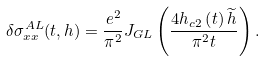<formula> <loc_0><loc_0><loc_500><loc_500>\delta \sigma _ { x x } ^ { A L } ( t , h ) = \frac { e ^ { 2 } } { \pi ^ { 2 } } J _ { G L } \left ( \frac { 4 h _ { c 2 } \left ( t \right ) \widetilde { h } } { \pi ^ { 2 } t } \right ) .</formula> 